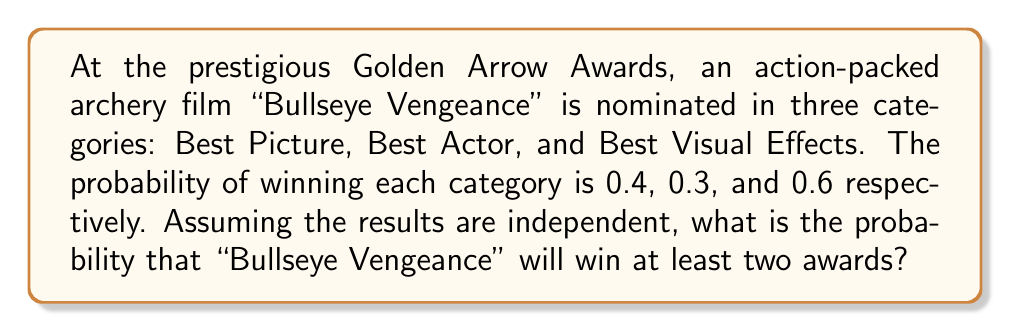Solve this math problem. Let's approach this step-by-step:

1) First, we need to calculate the probability of winning exactly 2 awards and exactly 3 awards, then sum these probabilities.

2) For winning exactly 2 awards, we have three possibilities:
   a) Win Best Picture and Best Actor: $0.4 \times 0.3 \times (1-0.6) = 0.048$
   b) Win Best Picture and Best Visual Effects: $0.4 \times (1-0.3) \times 0.6 = 0.168$
   c) Win Best Actor and Best Visual Effects: $(1-0.4) \times 0.3 \times 0.6 = 0.108$

3) The probability of winning exactly 2 awards is the sum of these:
   $P(\text{exactly 2}) = 0.048 + 0.168 + 0.108 = 0.324$

4) For winning all 3 awards:
   $P(\text{all 3}) = 0.4 \times 0.3 \times 0.6 = 0.072$

5) The probability of winning at least 2 awards is the sum of winning exactly 2 and winning all 3:
   $P(\text{at least 2}) = P(\text{exactly 2}) + P(\text{all 3}) = 0.324 + 0.072 = 0.396$

Therefore, the probability that "Bullseye Vengeance" will win at least two awards is 0.396 or 39.6%.
Answer: 0.396 